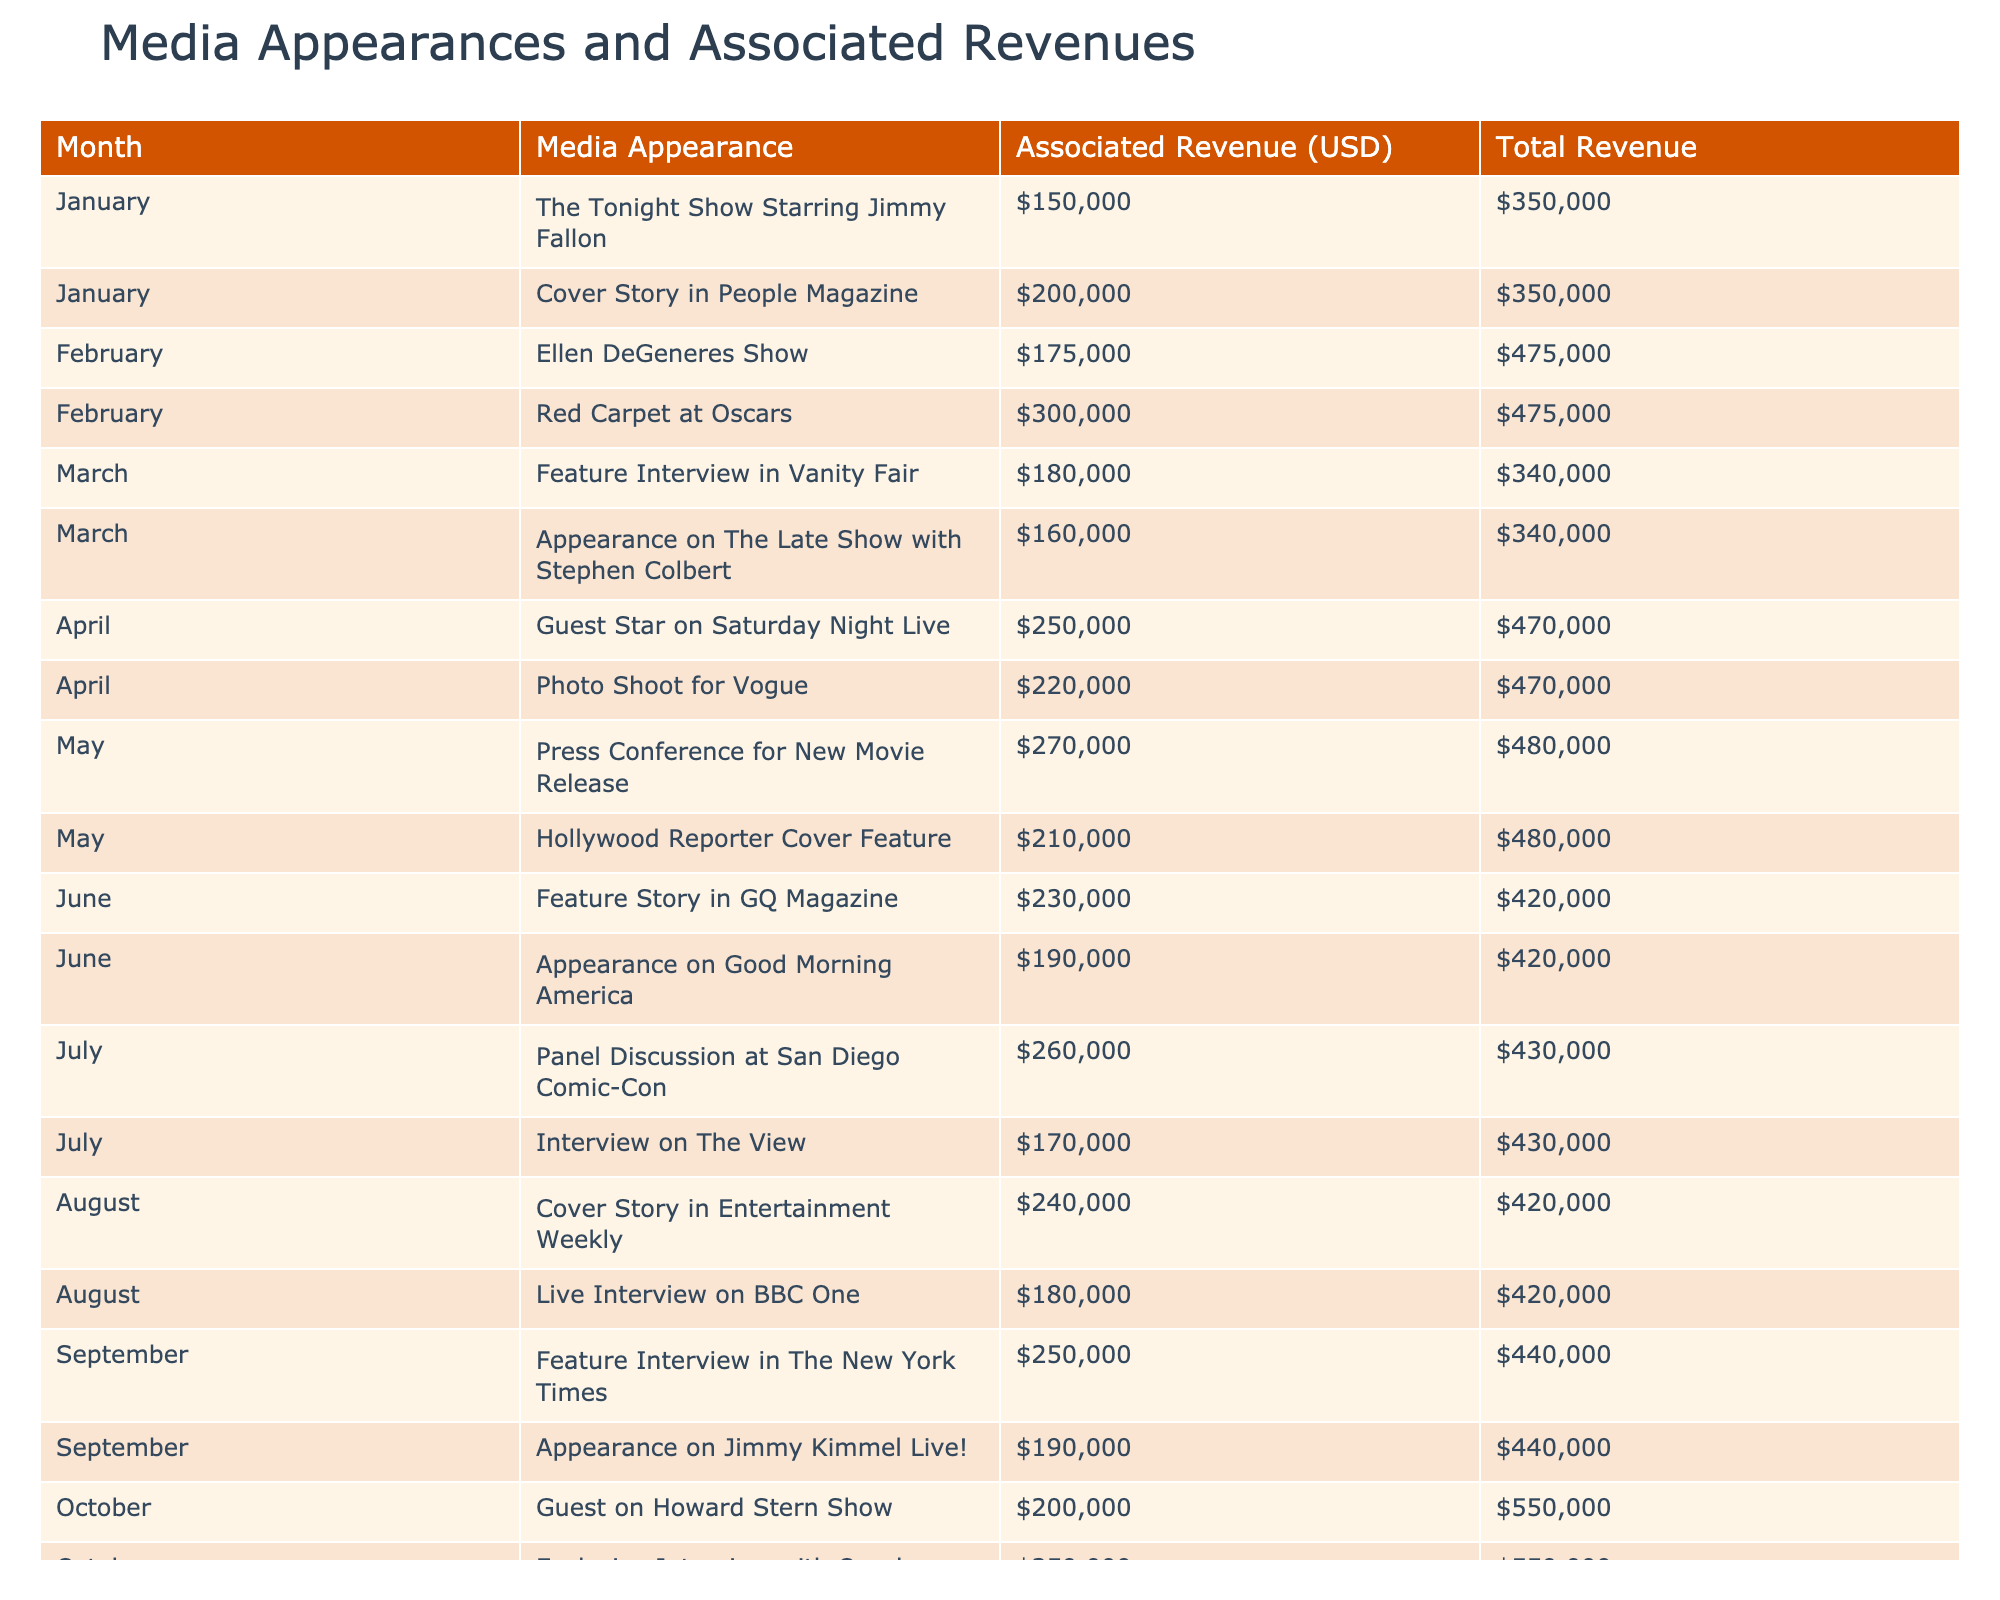What was the total revenue from media appearances in February? In February, there are two media appearances listed: Ellen DeGeneres Show with a revenue of 175,000 USD and Red Carpet at Oscars with a revenue of 300,000 USD. To get the total, we sum these values: 175,000 + 300,000 = 475,000 USD.
Answer: 475,000 USD Which media appearance in October had the highest associated revenue? In October, there are two media appearances: Guest on Howard Stern Show with a revenue of 200,000 USD and Exclusive Interview with Oprah with a revenue of 350,000 USD. The latter is higher, so the highest associated revenue in October is from the Exclusive Interview with Oprah.
Answer: Exclusive Interview with Oprah Did the media appearance on The Tonight Show Starring Jimmy Fallon have a higher revenue than the average revenue of all media appearances in March? The appearance on The Tonight Show Starring Jimmy Fallon in January generated 150,000 USD. In March, the total revenue made from two appearances (Feature Interview in Vanity Fair and Appearance on The Late Show with Stephen Colbert) is 180,000 + 160,000 = 340,000 USD. The average revenue in March is 340,000 / 2 = 170,000 USD. Since 150,000 USD is less than 170,000 USD, the statement is false.
Answer: No How much did the guest star on Saturday Night Live earn compared to the total revenue of media appearances in April? The guest appearance on Saturday Night Live earned 250,000 USD. In April, there are two appearances: Guest Star on Saturday Night Live (250,000 USD) and Photo Shoot for Vogue (220,000 USD). The total revenue for April is 250,000 + 220,000 = 470,000 USD. Therefore, the Guest Star on Saturday Night Live earned less than the total revenue for April.
Answer: Less What was the highest revenue achieved from a single media appearance throughout the year? The Exclusive Interview with Oprah in October had the highest associated revenue at 350,000 USD. By reviewing all appearances listed in the table, no other appearance exceeds this figure, confirming it as the highest amount.
Answer: 350,000 USD 